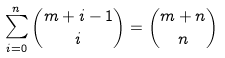<formula> <loc_0><loc_0><loc_500><loc_500>\sum _ { i = 0 } ^ { n } { \binom { m + i - 1 } { i } } = { \binom { m + n } { n } }</formula> 